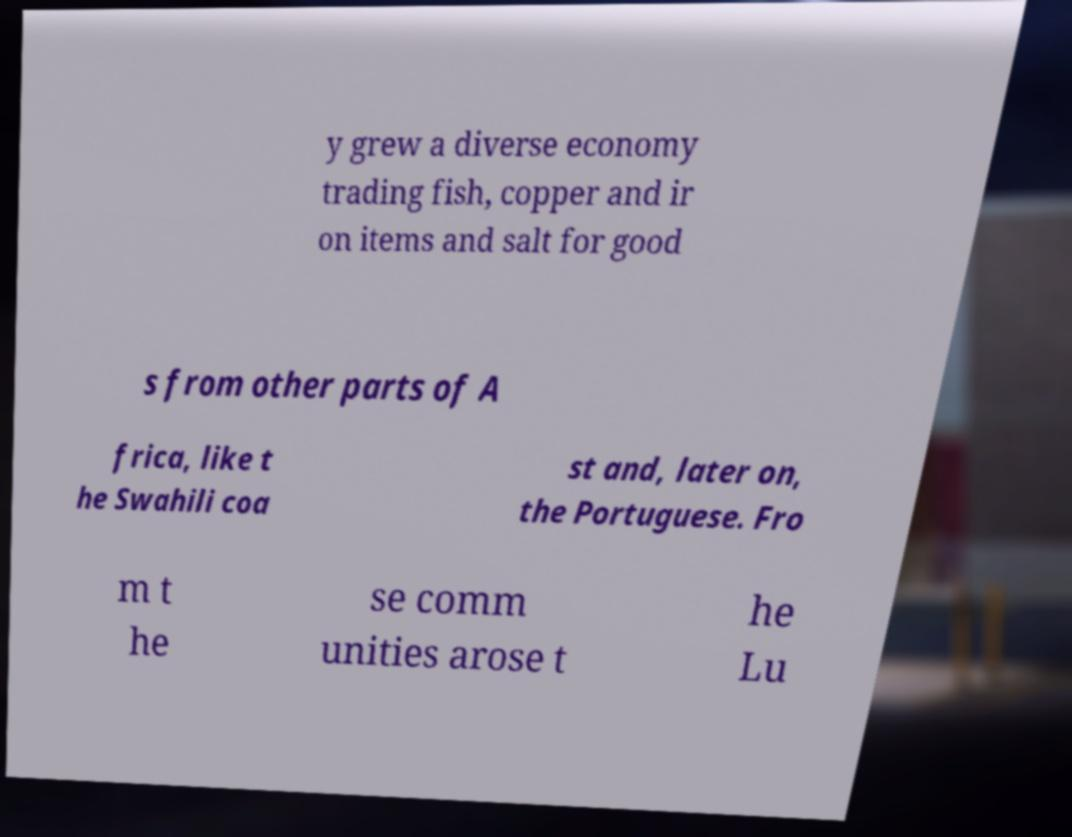Please read and relay the text visible in this image. What does it say? y grew a diverse economy trading fish, copper and ir on items and salt for good s from other parts of A frica, like t he Swahili coa st and, later on, the Portuguese. Fro m t he se comm unities arose t he Lu 